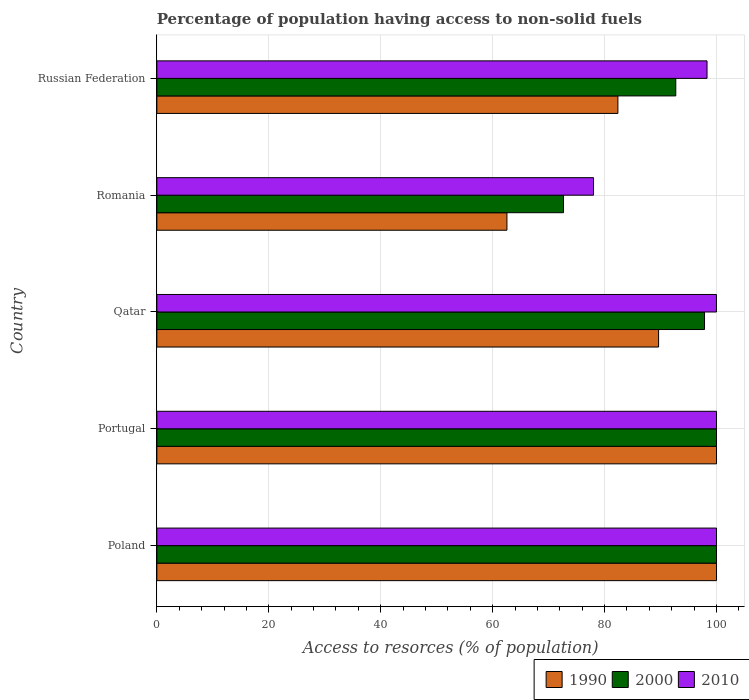Are the number of bars per tick equal to the number of legend labels?
Keep it short and to the point. Yes. How many bars are there on the 4th tick from the top?
Provide a succinct answer. 3. How many bars are there on the 3rd tick from the bottom?
Keep it short and to the point. 3. What is the label of the 2nd group of bars from the top?
Offer a terse response. Romania. In how many cases, is the number of bars for a given country not equal to the number of legend labels?
Offer a very short reply. 0. Across all countries, what is the minimum percentage of population having access to non-solid fuels in 2000?
Keep it short and to the point. 72.66. In which country was the percentage of population having access to non-solid fuels in 2010 minimum?
Your answer should be very brief. Romania. What is the total percentage of population having access to non-solid fuels in 1990 in the graph?
Provide a succinct answer. 434.58. What is the difference between the percentage of population having access to non-solid fuels in 2000 in Poland and that in Russian Federation?
Your answer should be very brief. 7.28. What is the difference between the percentage of population having access to non-solid fuels in 2010 in Qatar and the percentage of population having access to non-solid fuels in 1990 in Portugal?
Keep it short and to the point. -0.01. What is the average percentage of population having access to non-solid fuels in 2000 per country?
Make the answer very short. 92.65. What is the difference between the percentage of population having access to non-solid fuels in 2000 and percentage of population having access to non-solid fuels in 2010 in Russian Federation?
Make the answer very short. -5.59. In how many countries, is the percentage of population having access to non-solid fuels in 2000 greater than 48 %?
Your answer should be very brief. 5. What is the ratio of the percentage of population having access to non-solid fuels in 2010 in Portugal to that in Russian Federation?
Give a very brief answer. 1.02. What is the difference between the highest and the second highest percentage of population having access to non-solid fuels in 2000?
Offer a terse response. 0. What is the difference between the highest and the lowest percentage of population having access to non-solid fuels in 2000?
Your response must be concise. 27.34. What does the 1st bar from the top in Poland represents?
Give a very brief answer. 2010. What does the 2nd bar from the bottom in Qatar represents?
Your answer should be compact. 2000. How many bars are there?
Keep it short and to the point. 15. How many countries are there in the graph?
Your answer should be very brief. 5. What is the difference between two consecutive major ticks on the X-axis?
Give a very brief answer. 20. How many legend labels are there?
Ensure brevity in your answer.  3. How are the legend labels stacked?
Provide a short and direct response. Horizontal. What is the title of the graph?
Offer a terse response. Percentage of population having access to non-solid fuels. What is the label or title of the X-axis?
Offer a terse response. Access to resorces (% of population). What is the Access to resorces (% of population) of 1990 in Poland?
Provide a succinct answer. 100. What is the Access to resorces (% of population) in 2000 in Poland?
Provide a succinct answer. 100. What is the Access to resorces (% of population) in 2010 in Poland?
Provide a short and direct response. 100. What is the Access to resorces (% of population) in 1990 in Portugal?
Your answer should be compact. 100. What is the Access to resorces (% of population) of 2010 in Portugal?
Ensure brevity in your answer.  100. What is the Access to resorces (% of population) of 1990 in Qatar?
Provide a short and direct response. 89.65. What is the Access to resorces (% of population) of 2000 in Qatar?
Keep it short and to the point. 97.86. What is the Access to resorces (% of population) in 2010 in Qatar?
Provide a short and direct response. 99.99. What is the Access to resorces (% of population) in 1990 in Romania?
Give a very brief answer. 62.55. What is the Access to resorces (% of population) of 2000 in Romania?
Offer a very short reply. 72.66. What is the Access to resorces (% of population) in 2010 in Romania?
Offer a terse response. 78.03. What is the Access to resorces (% of population) in 1990 in Russian Federation?
Ensure brevity in your answer.  82.38. What is the Access to resorces (% of population) of 2000 in Russian Federation?
Make the answer very short. 92.72. What is the Access to resorces (% of population) of 2010 in Russian Federation?
Your response must be concise. 98.31. Across all countries, what is the maximum Access to resorces (% of population) of 2000?
Provide a succinct answer. 100. Across all countries, what is the minimum Access to resorces (% of population) of 1990?
Keep it short and to the point. 62.55. Across all countries, what is the minimum Access to resorces (% of population) of 2000?
Make the answer very short. 72.66. Across all countries, what is the minimum Access to resorces (% of population) of 2010?
Your answer should be compact. 78.03. What is the total Access to resorces (% of population) in 1990 in the graph?
Give a very brief answer. 434.58. What is the total Access to resorces (% of population) in 2000 in the graph?
Provide a succinct answer. 463.24. What is the total Access to resorces (% of population) in 2010 in the graph?
Your answer should be very brief. 476.32. What is the difference between the Access to resorces (% of population) of 2010 in Poland and that in Portugal?
Ensure brevity in your answer.  0. What is the difference between the Access to resorces (% of population) in 1990 in Poland and that in Qatar?
Provide a short and direct response. 10.35. What is the difference between the Access to resorces (% of population) in 2000 in Poland and that in Qatar?
Provide a short and direct response. 2.14. What is the difference between the Access to resorces (% of population) in 1990 in Poland and that in Romania?
Ensure brevity in your answer.  37.45. What is the difference between the Access to resorces (% of population) of 2000 in Poland and that in Romania?
Provide a short and direct response. 27.34. What is the difference between the Access to resorces (% of population) in 2010 in Poland and that in Romania?
Keep it short and to the point. 21.97. What is the difference between the Access to resorces (% of population) in 1990 in Poland and that in Russian Federation?
Give a very brief answer. 17.62. What is the difference between the Access to resorces (% of population) in 2000 in Poland and that in Russian Federation?
Offer a very short reply. 7.28. What is the difference between the Access to resorces (% of population) in 2010 in Poland and that in Russian Federation?
Provide a short and direct response. 1.69. What is the difference between the Access to resorces (% of population) in 1990 in Portugal and that in Qatar?
Ensure brevity in your answer.  10.35. What is the difference between the Access to resorces (% of population) of 2000 in Portugal and that in Qatar?
Your response must be concise. 2.14. What is the difference between the Access to resorces (% of population) of 2010 in Portugal and that in Qatar?
Keep it short and to the point. 0.01. What is the difference between the Access to resorces (% of population) in 1990 in Portugal and that in Romania?
Give a very brief answer. 37.45. What is the difference between the Access to resorces (% of population) of 2000 in Portugal and that in Romania?
Provide a succinct answer. 27.34. What is the difference between the Access to resorces (% of population) of 2010 in Portugal and that in Romania?
Give a very brief answer. 21.97. What is the difference between the Access to resorces (% of population) in 1990 in Portugal and that in Russian Federation?
Your answer should be compact. 17.62. What is the difference between the Access to resorces (% of population) of 2000 in Portugal and that in Russian Federation?
Keep it short and to the point. 7.28. What is the difference between the Access to resorces (% of population) in 2010 in Portugal and that in Russian Federation?
Ensure brevity in your answer.  1.69. What is the difference between the Access to resorces (% of population) of 1990 in Qatar and that in Romania?
Give a very brief answer. 27.1. What is the difference between the Access to resorces (% of population) in 2000 in Qatar and that in Romania?
Offer a terse response. 25.2. What is the difference between the Access to resorces (% of population) of 2010 in Qatar and that in Romania?
Offer a terse response. 21.96. What is the difference between the Access to resorces (% of population) in 1990 in Qatar and that in Russian Federation?
Your answer should be very brief. 7.27. What is the difference between the Access to resorces (% of population) in 2000 in Qatar and that in Russian Federation?
Your answer should be compact. 5.14. What is the difference between the Access to resorces (% of population) of 2010 in Qatar and that in Russian Federation?
Offer a terse response. 1.68. What is the difference between the Access to resorces (% of population) of 1990 in Romania and that in Russian Federation?
Provide a short and direct response. -19.83. What is the difference between the Access to resorces (% of population) in 2000 in Romania and that in Russian Federation?
Ensure brevity in your answer.  -20.06. What is the difference between the Access to resorces (% of population) of 2010 in Romania and that in Russian Federation?
Your response must be concise. -20.28. What is the difference between the Access to resorces (% of population) of 1990 in Poland and the Access to resorces (% of population) of 2010 in Portugal?
Your answer should be compact. 0. What is the difference between the Access to resorces (% of population) of 2000 in Poland and the Access to resorces (% of population) of 2010 in Portugal?
Ensure brevity in your answer.  0. What is the difference between the Access to resorces (% of population) of 1990 in Poland and the Access to resorces (% of population) of 2000 in Qatar?
Make the answer very short. 2.14. What is the difference between the Access to resorces (% of population) of 1990 in Poland and the Access to resorces (% of population) of 2010 in Qatar?
Provide a short and direct response. 0.01. What is the difference between the Access to resorces (% of population) of 2000 in Poland and the Access to resorces (% of population) of 2010 in Qatar?
Give a very brief answer. 0.01. What is the difference between the Access to resorces (% of population) of 1990 in Poland and the Access to resorces (% of population) of 2000 in Romania?
Make the answer very short. 27.34. What is the difference between the Access to resorces (% of population) of 1990 in Poland and the Access to resorces (% of population) of 2010 in Romania?
Provide a succinct answer. 21.97. What is the difference between the Access to resorces (% of population) in 2000 in Poland and the Access to resorces (% of population) in 2010 in Romania?
Offer a very short reply. 21.97. What is the difference between the Access to resorces (% of population) in 1990 in Poland and the Access to resorces (% of population) in 2000 in Russian Federation?
Provide a succinct answer. 7.28. What is the difference between the Access to resorces (% of population) in 1990 in Poland and the Access to resorces (% of population) in 2010 in Russian Federation?
Make the answer very short. 1.69. What is the difference between the Access to resorces (% of population) of 2000 in Poland and the Access to resorces (% of population) of 2010 in Russian Federation?
Give a very brief answer. 1.69. What is the difference between the Access to resorces (% of population) of 1990 in Portugal and the Access to resorces (% of population) of 2000 in Qatar?
Give a very brief answer. 2.14. What is the difference between the Access to resorces (% of population) of 1990 in Portugal and the Access to resorces (% of population) of 2000 in Romania?
Provide a short and direct response. 27.34. What is the difference between the Access to resorces (% of population) of 1990 in Portugal and the Access to resorces (% of population) of 2010 in Romania?
Your answer should be compact. 21.97. What is the difference between the Access to resorces (% of population) in 2000 in Portugal and the Access to resorces (% of population) in 2010 in Romania?
Give a very brief answer. 21.97. What is the difference between the Access to resorces (% of population) in 1990 in Portugal and the Access to resorces (% of population) in 2000 in Russian Federation?
Give a very brief answer. 7.28. What is the difference between the Access to resorces (% of population) in 1990 in Portugal and the Access to resorces (% of population) in 2010 in Russian Federation?
Your response must be concise. 1.69. What is the difference between the Access to resorces (% of population) in 2000 in Portugal and the Access to resorces (% of population) in 2010 in Russian Federation?
Provide a short and direct response. 1.69. What is the difference between the Access to resorces (% of population) of 1990 in Qatar and the Access to resorces (% of population) of 2000 in Romania?
Provide a short and direct response. 16.99. What is the difference between the Access to resorces (% of population) of 1990 in Qatar and the Access to resorces (% of population) of 2010 in Romania?
Ensure brevity in your answer.  11.62. What is the difference between the Access to resorces (% of population) of 2000 in Qatar and the Access to resorces (% of population) of 2010 in Romania?
Your response must be concise. 19.83. What is the difference between the Access to resorces (% of population) in 1990 in Qatar and the Access to resorces (% of population) in 2000 in Russian Federation?
Make the answer very short. -3.07. What is the difference between the Access to resorces (% of population) of 1990 in Qatar and the Access to resorces (% of population) of 2010 in Russian Federation?
Your answer should be compact. -8.66. What is the difference between the Access to resorces (% of population) of 2000 in Qatar and the Access to resorces (% of population) of 2010 in Russian Federation?
Offer a very short reply. -0.45. What is the difference between the Access to resorces (% of population) of 1990 in Romania and the Access to resorces (% of population) of 2000 in Russian Federation?
Your answer should be very brief. -30.17. What is the difference between the Access to resorces (% of population) of 1990 in Romania and the Access to resorces (% of population) of 2010 in Russian Federation?
Offer a very short reply. -35.75. What is the difference between the Access to resorces (% of population) of 2000 in Romania and the Access to resorces (% of population) of 2010 in Russian Federation?
Keep it short and to the point. -25.65. What is the average Access to resorces (% of population) of 1990 per country?
Your answer should be compact. 86.92. What is the average Access to resorces (% of population) of 2000 per country?
Your answer should be very brief. 92.65. What is the average Access to resorces (% of population) of 2010 per country?
Your answer should be very brief. 95.26. What is the difference between the Access to resorces (% of population) in 1990 and Access to resorces (% of population) in 2010 in Portugal?
Ensure brevity in your answer.  0. What is the difference between the Access to resorces (% of population) in 1990 and Access to resorces (% of population) in 2000 in Qatar?
Your answer should be very brief. -8.21. What is the difference between the Access to resorces (% of population) in 1990 and Access to resorces (% of population) in 2010 in Qatar?
Keep it short and to the point. -10.34. What is the difference between the Access to resorces (% of population) in 2000 and Access to resorces (% of population) in 2010 in Qatar?
Your answer should be compact. -2.13. What is the difference between the Access to resorces (% of population) of 1990 and Access to resorces (% of population) of 2000 in Romania?
Your response must be concise. -10.11. What is the difference between the Access to resorces (% of population) in 1990 and Access to resorces (% of population) in 2010 in Romania?
Offer a terse response. -15.47. What is the difference between the Access to resorces (% of population) of 2000 and Access to resorces (% of population) of 2010 in Romania?
Offer a terse response. -5.37. What is the difference between the Access to resorces (% of population) in 1990 and Access to resorces (% of population) in 2000 in Russian Federation?
Provide a short and direct response. -10.34. What is the difference between the Access to resorces (% of population) in 1990 and Access to resorces (% of population) in 2010 in Russian Federation?
Ensure brevity in your answer.  -15.93. What is the difference between the Access to resorces (% of population) in 2000 and Access to resorces (% of population) in 2010 in Russian Federation?
Provide a succinct answer. -5.59. What is the ratio of the Access to resorces (% of population) of 1990 in Poland to that in Portugal?
Your answer should be very brief. 1. What is the ratio of the Access to resorces (% of population) of 2000 in Poland to that in Portugal?
Make the answer very short. 1. What is the ratio of the Access to resorces (% of population) of 2010 in Poland to that in Portugal?
Your response must be concise. 1. What is the ratio of the Access to resorces (% of population) of 1990 in Poland to that in Qatar?
Keep it short and to the point. 1.12. What is the ratio of the Access to resorces (% of population) in 2000 in Poland to that in Qatar?
Your answer should be compact. 1.02. What is the ratio of the Access to resorces (% of population) in 2010 in Poland to that in Qatar?
Give a very brief answer. 1. What is the ratio of the Access to resorces (% of population) of 1990 in Poland to that in Romania?
Offer a terse response. 1.6. What is the ratio of the Access to resorces (% of population) in 2000 in Poland to that in Romania?
Provide a succinct answer. 1.38. What is the ratio of the Access to resorces (% of population) in 2010 in Poland to that in Romania?
Your response must be concise. 1.28. What is the ratio of the Access to resorces (% of population) of 1990 in Poland to that in Russian Federation?
Keep it short and to the point. 1.21. What is the ratio of the Access to resorces (% of population) of 2000 in Poland to that in Russian Federation?
Keep it short and to the point. 1.08. What is the ratio of the Access to resorces (% of population) in 2010 in Poland to that in Russian Federation?
Offer a very short reply. 1.02. What is the ratio of the Access to resorces (% of population) in 1990 in Portugal to that in Qatar?
Make the answer very short. 1.12. What is the ratio of the Access to resorces (% of population) in 2000 in Portugal to that in Qatar?
Give a very brief answer. 1.02. What is the ratio of the Access to resorces (% of population) in 1990 in Portugal to that in Romania?
Give a very brief answer. 1.6. What is the ratio of the Access to resorces (% of population) of 2000 in Portugal to that in Romania?
Ensure brevity in your answer.  1.38. What is the ratio of the Access to resorces (% of population) in 2010 in Portugal to that in Romania?
Provide a succinct answer. 1.28. What is the ratio of the Access to resorces (% of population) of 1990 in Portugal to that in Russian Federation?
Provide a short and direct response. 1.21. What is the ratio of the Access to resorces (% of population) in 2000 in Portugal to that in Russian Federation?
Your response must be concise. 1.08. What is the ratio of the Access to resorces (% of population) in 2010 in Portugal to that in Russian Federation?
Your answer should be compact. 1.02. What is the ratio of the Access to resorces (% of population) of 1990 in Qatar to that in Romania?
Your answer should be compact. 1.43. What is the ratio of the Access to resorces (% of population) of 2000 in Qatar to that in Romania?
Offer a very short reply. 1.35. What is the ratio of the Access to resorces (% of population) of 2010 in Qatar to that in Romania?
Ensure brevity in your answer.  1.28. What is the ratio of the Access to resorces (% of population) in 1990 in Qatar to that in Russian Federation?
Keep it short and to the point. 1.09. What is the ratio of the Access to resorces (% of population) in 2000 in Qatar to that in Russian Federation?
Keep it short and to the point. 1.06. What is the ratio of the Access to resorces (% of population) of 2010 in Qatar to that in Russian Federation?
Provide a short and direct response. 1.02. What is the ratio of the Access to resorces (% of population) in 1990 in Romania to that in Russian Federation?
Ensure brevity in your answer.  0.76. What is the ratio of the Access to resorces (% of population) of 2000 in Romania to that in Russian Federation?
Ensure brevity in your answer.  0.78. What is the ratio of the Access to resorces (% of population) in 2010 in Romania to that in Russian Federation?
Ensure brevity in your answer.  0.79. What is the difference between the highest and the second highest Access to resorces (% of population) of 1990?
Offer a very short reply. 0. What is the difference between the highest and the second highest Access to resorces (% of population) of 2000?
Your response must be concise. 0. What is the difference between the highest and the lowest Access to resorces (% of population) of 1990?
Your answer should be very brief. 37.45. What is the difference between the highest and the lowest Access to resorces (% of population) in 2000?
Offer a very short reply. 27.34. What is the difference between the highest and the lowest Access to resorces (% of population) of 2010?
Give a very brief answer. 21.97. 